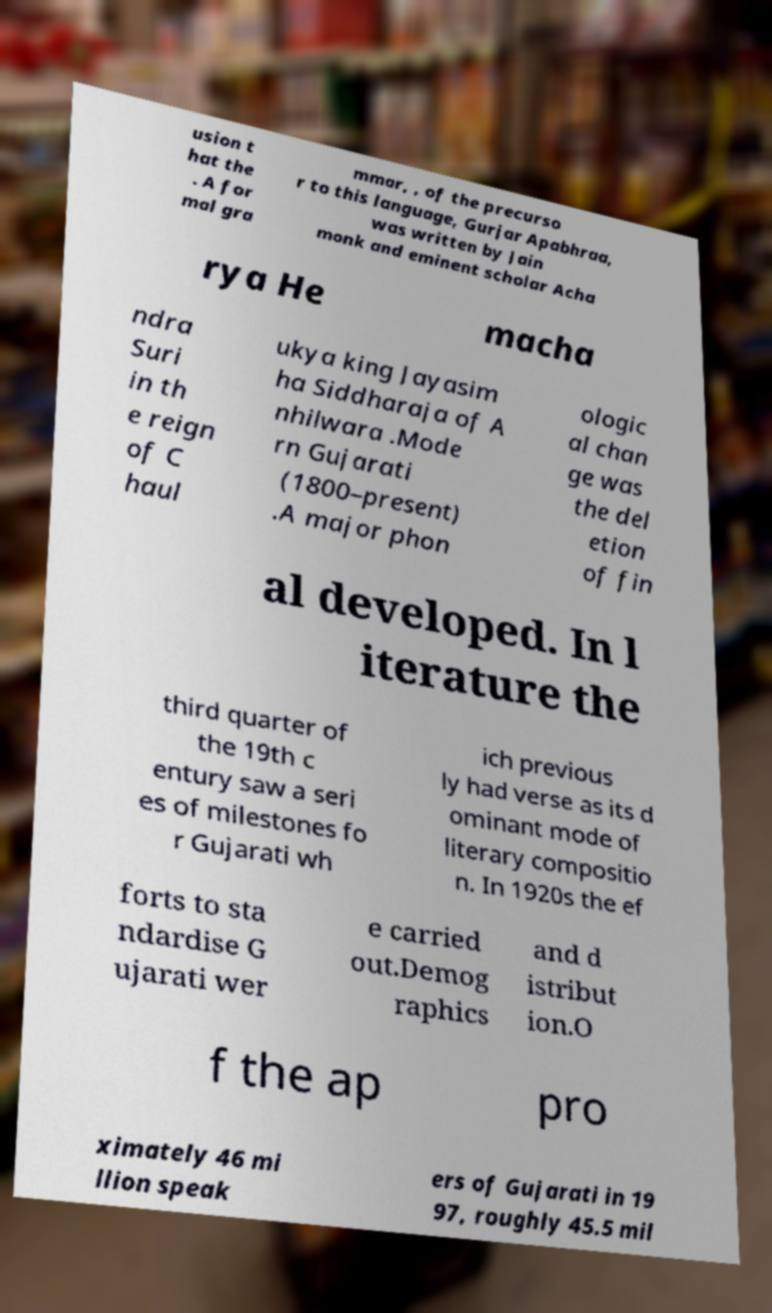Please read and relay the text visible in this image. What does it say? usion t hat the . A for mal gra mmar, , of the precurso r to this language, Gurjar Apabhraa, was written by Jain monk and eminent scholar Acha rya He macha ndra Suri in th e reign of C haul ukya king Jayasim ha Siddharaja of A nhilwara .Mode rn Gujarati (1800–present) .A major phon ologic al chan ge was the del etion of fin al developed. In l iterature the third quarter of the 19th c entury saw a seri es of milestones fo r Gujarati wh ich previous ly had verse as its d ominant mode of literary compositio n. In 1920s the ef forts to sta ndardise G ujarati wer e carried out.Demog raphics and d istribut ion.O f the ap pro ximately 46 mi llion speak ers of Gujarati in 19 97, roughly 45.5 mil 